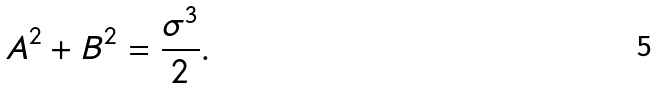Convert formula to latex. <formula><loc_0><loc_0><loc_500><loc_500>A ^ { 2 } + B ^ { 2 } = \frac { \sigma ^ { 3 } } { 2 } .</formula> 